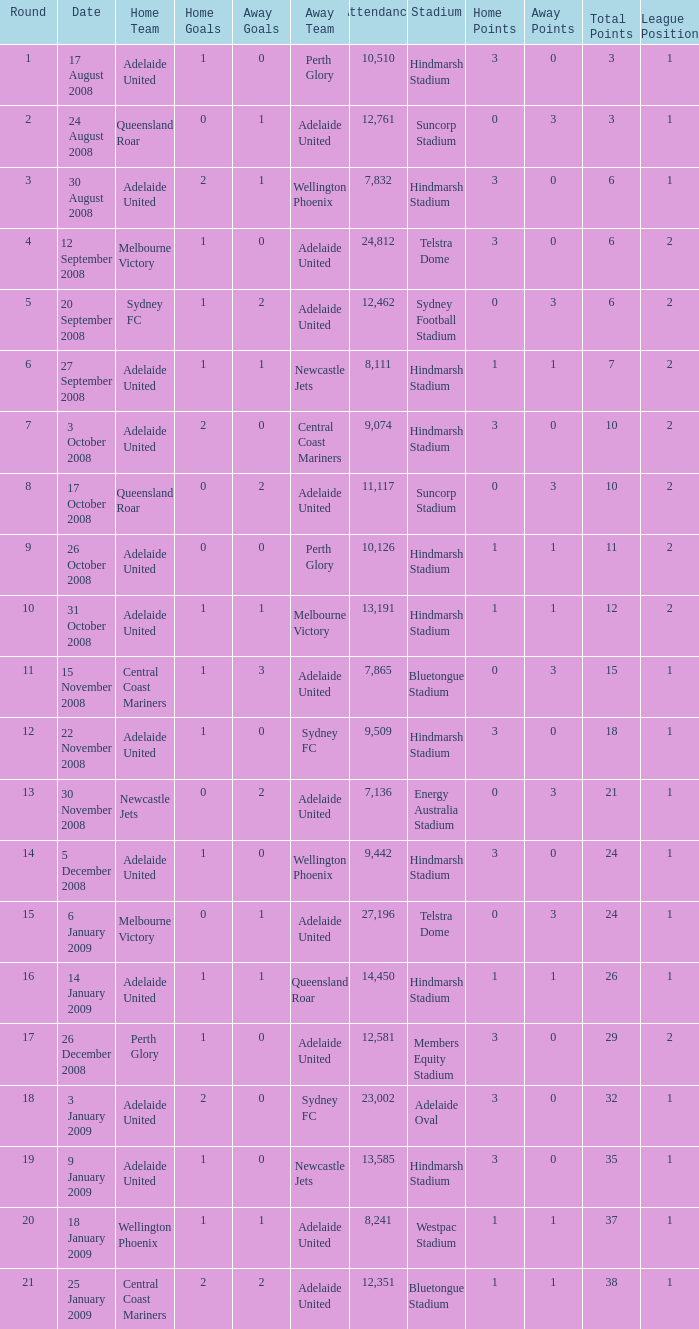What is the least round for the game played at Members Equity Stadium in from of 12,581 people? None. 